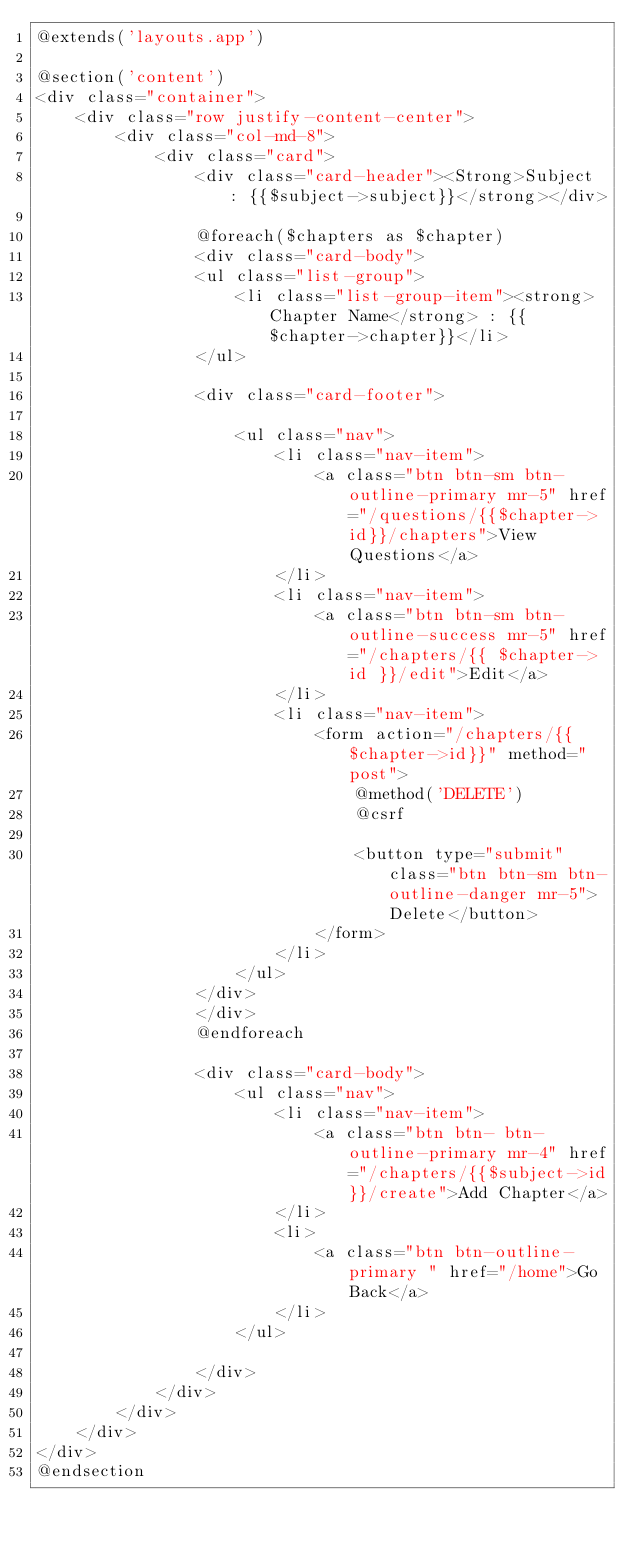<code> <loc_0><loc_0><loc_500><loc_500><_PHP_>@extends('layouts.app')

@section('content')
<div class="container">
    <div class="row justify-content-center">
        <div class="col-md-8">
            <div class="card">
                <div class="card-header"><Strong>Subject : {{$subject->subject}}</strong></div>

                @foreach($chapters as $chapter)
                <div class="card-body">
                <ul class="list-group">
                    <li class="list-group-item"><strong>Chapter Name</strong> : {{ $chapter->chapter}}</li>
                </ul>

                <div class="card-footer">

                    <ul class="nav">
                        <li class="nav-item">
                            <a class="btn btn-sm btn-outline-primary mr-5" href="/questions/{{$chapter->id}}/chapters">View Questions</a>
                        </li>
                        <li class="nav-item">
                            <a class="btn btn-sm btn-outline-success mr-5" href="/chapters/{{ $chapter->id }}/edit">Edit</a>
                        </li>
                        <li class="nav-item">
                            <form action="/chapters/{{$chapter->id}}" method="post">
                                @method('DELETE')
                                @csrf

                                <button type="submit" class="btn btn-sm btn-outline-danger mr-5">Delete</button>
                            </form>
                        </li>
                    </ul>
                </div>
                </div>
                @endforeach
                
                <div class="card-body">
                    <ul class="nav">
                        <li class="nav-item">
                            <a class="btn btn- btn-outline-primary mr-4" href="/chapters/{{$subject->id}}/create">Add Chapter</a>
                        </li>
                        <li>
                            <a class="btn btn-outline-primary " href="/home">Go Back</a>
                        </li>
                    </ul>
                    
                </div>
            </div>
        </div>
    </div>
</div>
@endsection
</code> 